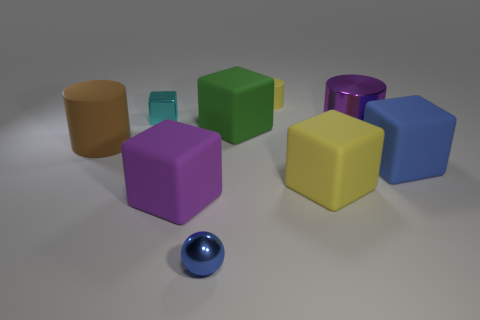Subtract 1 cubes. How many cubes are left? 4 Subtract all yellow cubes. How many cubes are left? 4 Subtract all purple cubes. How many cubes are left? 4 Subtract all gray blocks. Subtract all yellow spheres. How many blocks are left? 5 Add 1 blue matte cubes. How many objects exist? 10 Subtract all cylinders. How many objects are left? 6 Subtract 1 yellow blocks. How many objects are left? 8 Subtract all small cyan objects. Subtract all small yellow things. How many objects are left? 7 Add 8 large green things. How many large green things are left? 9 Add 8 small shiny balls. How many small shiny balls exist? 9 